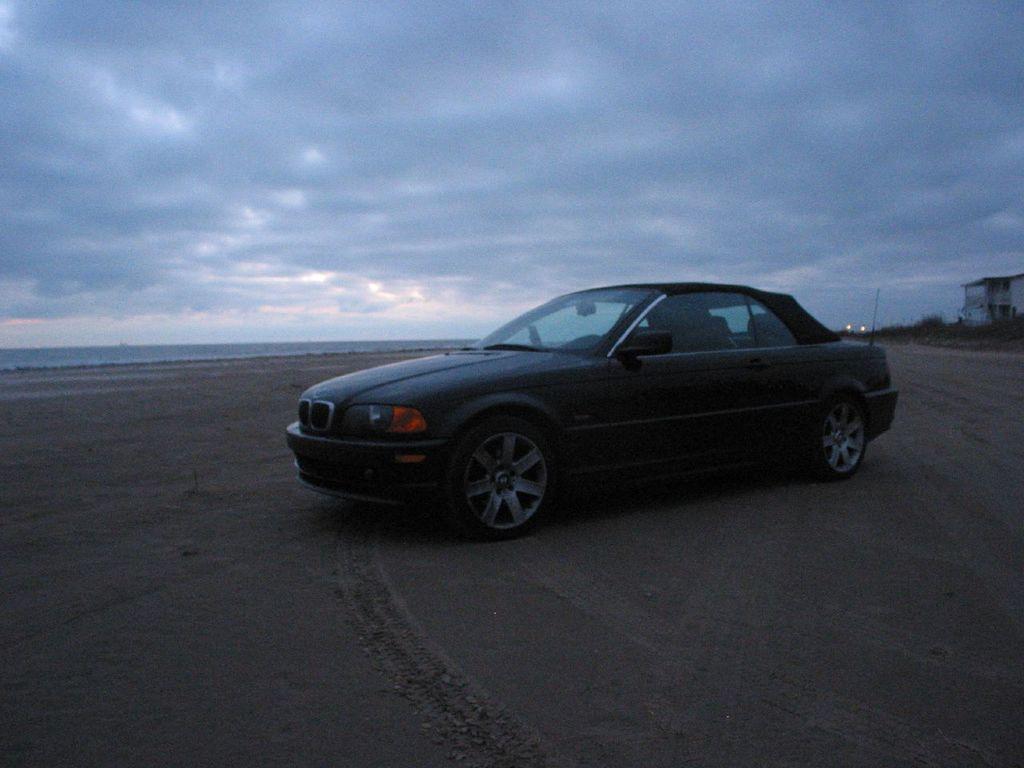Please provide a concise description of this image. In this image, we can see a vehicle. We can see the ground. We can also see some objects on the right. We can also see the sky with clouds. 